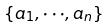<formula> <loc_0><loc_0><loc_500><loc_500>\{ a _ { 1 } , \cdot \cdot \cdot , a _ { n } \}</formula> 